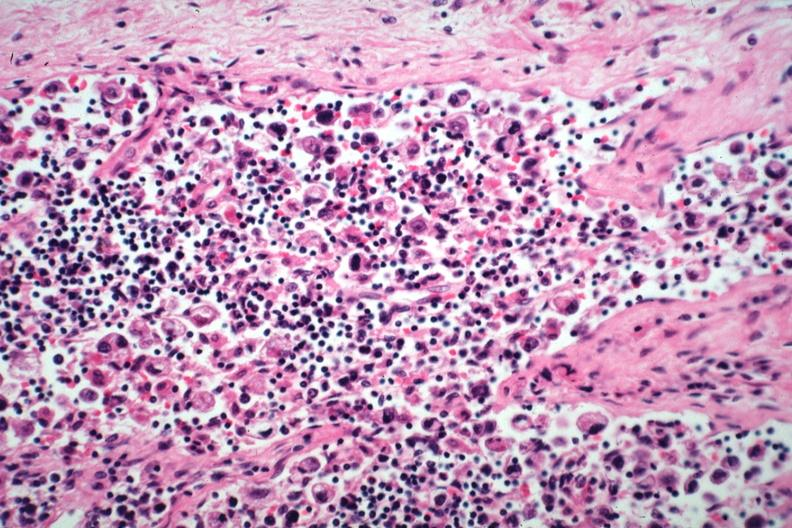does this image show anaplastic adenocarcinoma from stomach?
Answer the question using a single word or phrase. Yes 